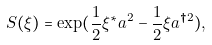<formula> <loc_0><loc_0><loc_500><loc_500>S ( \xi ) = \exp ( \frac { 1 } { 2 } \xi ^ { \ast } a ^ { 2 } - \frac { 1 } { 2 } \xi a ^ { \dagger 2 } ) ,</formula> 